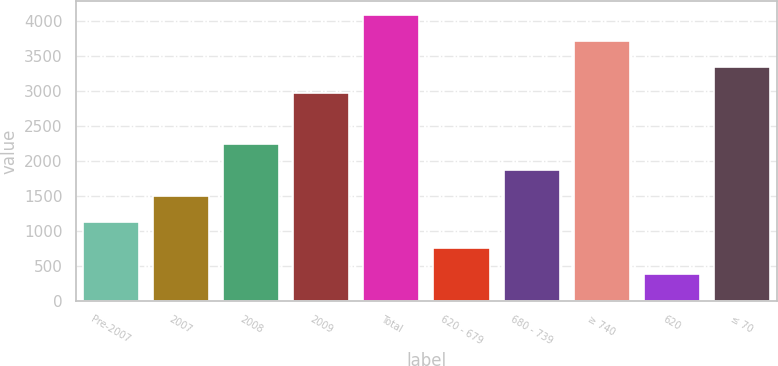Convert chart. <chart><loc_0><loc_0><loc_500><loc_500><bar_chart><fcel>Pre-2007<fcel>2007<fcel>2008<fcel>2009<fcel>Total<fcel>620 - 679<fcel>680 - 739<fcel>≥ 740<fcel>620<fcel>≤ 70<nl><fcel>1130.5<fcel>1499<fcel>2236<fcel>2973<fcel>4078.5<fcel>762<fcel>1867.5<fcel>3710<fcel>393.5<fcel>3341.5<nl></chart> 